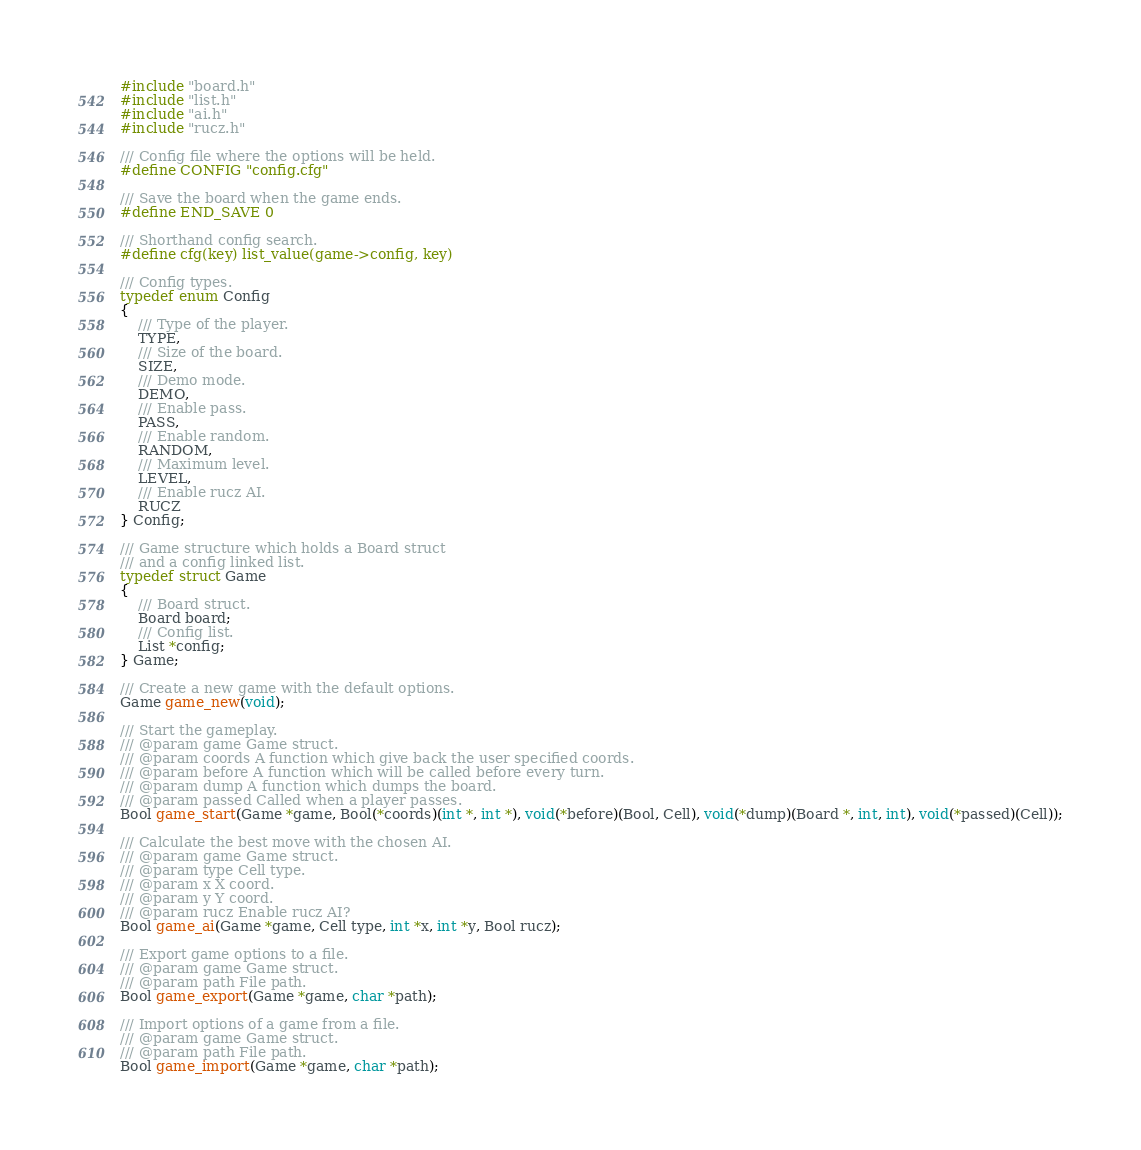<code> <loc_0><loc_0><loc_500><loc_500><_C_>#include "board.h"
#include "list.h"
#include "ai.h"
#include "rucz.h"

/// Config file where the options will be held.
#define CONFIG "config.cfg"

/// Save the board when the game ends.
#define END_SAVE 0

/// Shorthand config search.
#define cfg(key) list_value(game->config, key)

/// Config types.
typedef enum Config
{
	/// Type of the player.
	TYPE,
	/// Size of the board.
	SIZE,
	/// Demo mode.
	DEMO,
	/// Enable pass.
	PASS,
	/// Enable random.
	RANDOM,
	/// Maximum level.
	LEVEL,
	/// Enable rucz AI.
	RUCZ
} Config;

/// Game structure which holds a Board struct 
/// and a config linked list.
typedef struct Game
{
	/// Board struct.
	Board board;
	/// Config list.
	List *config;
} Game;

/// Create a new game with the default options.
Game game_new(void);

/// Start the gameplay.
/// @param game Game struct.
/// @param coords A function which give back the user specified coords.
/// @param before A function which will be called before every turn.
/// @param dump A function which dumps the board.
/// @param passed Called when a player passes.
Bool game_start(Game *game, Bool(*coords)(int *, int *), void(*before)(Bool, Cell), void(*dump)(Board *, int, int), void(*passed)(Cell));

/// Calculate the best move with the chosen AI.
/// @param game Game struct.
/// @param type Cell type.
/// @param x X coord.
/// @param y Y coord.
/// @param rucz Enable rucz AI?
Bool game_ai(Game *game, Cell type, int *x, int *y, Bool rucz);

/// Export game options to a file.
/// @param game Game struct.
/// @param path File path.
Bool game_export(Game *game, char *path);

/// Import options of a game from a file.
/// @param game Game struct.
/// @param path File path.
Bool game_import(Game *game, char *path);
</code> 